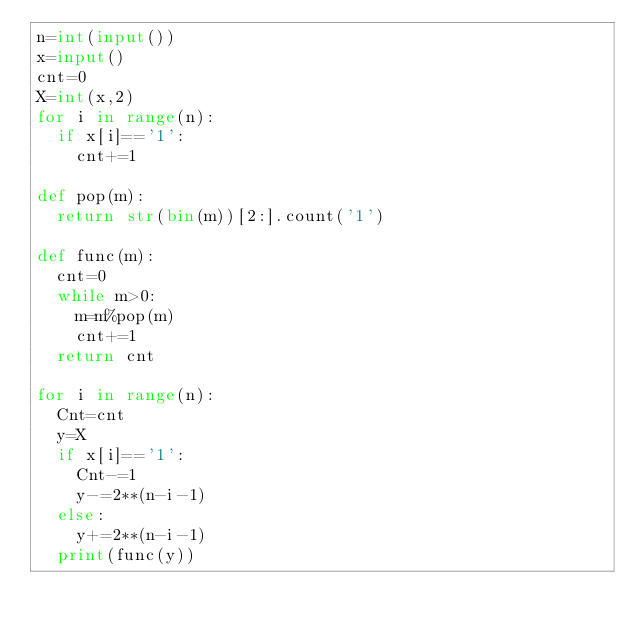<code> <loc_0><loc_0><loc_500><loc_500><_Python_>n=int(input())
x=input()
cnt=0
X=int(x,2)
for i in range(n):
  if x[i]=='1':
    cnt+=1
    
def pop(m):
  return str(bin(m))[2:].count('1')

def func(m):
  cnt=0
  while m>0:
    m=m%pop(m)
    cnt+=1
  return cnt
    
for i in range(n):
  Cnt=cnt
  y=X
  if x[i]=='1':
    Cnt-=1
    y-=2**(n-i-1)
  else:
    y+=2**(n-i-1)
  print(func(y))
</code> 